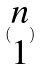Convert formula to latex. <formula><loc_0><loc_0><loc_500><loc_500>( \begin{matrix} n \\ 1 \end{matrix} )</formula> 